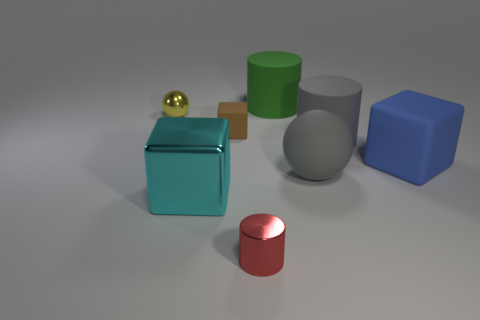Subtract all gray balls. Subtract all purple cylinders. How many balls are left? 1 Add 1 tiny metal objects. How many objects exist? 9 Subtract all balls. How many objects are left? 6 Subtract all small brown metallic objects. Subtract all large cyan metal things. How many objects are left? 7 Add 1 blue things. How many blue things are left? 2 Add 2 big blocks. How many big blocks exist? 4 Subtract 1 cyan cubes. How many objects are left? 7 